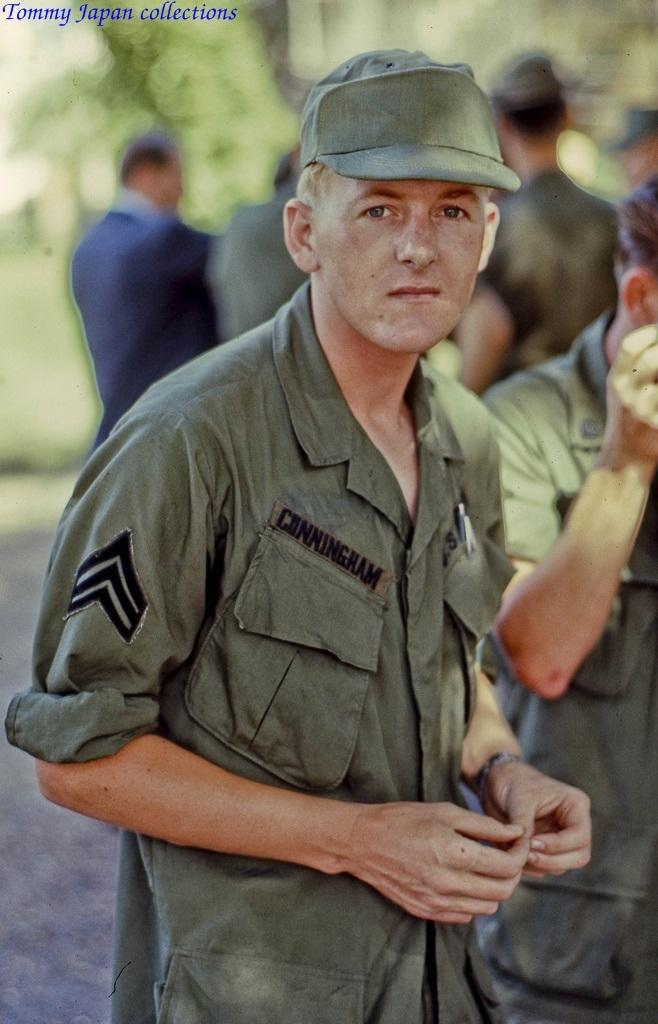Who is the main subject in the image? There is a man in the image. What is the man wearing? The man is wearing a uniform. Are there any other people visible in the image? Yes, there are other people behind the man. What can be seen in the top left corner of the image? There is some text in the top left corner of the image. What type of plough is being used by the man in the image? There is no plough present in the image; the man is wearing a uniform and there are other people behind him. Is the man in the image preparing for a flight? There is no indication in the image that the man is preparing for a flight or that he is associated with aviation. 